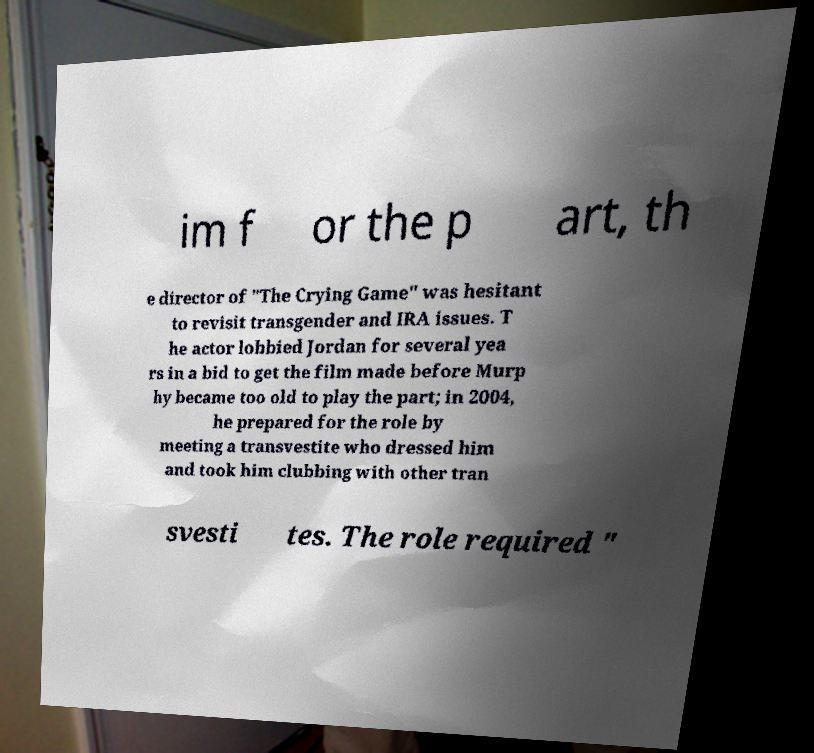Could you assist in decoding the text presented in this image and type it out clearly? im f or the p art, th e director of "The Crying Game" was hesitant to revisit transgender and IRA issues. T he actor lobbied Jordan for several yea rs in a bid to get the film made before Murp hy became too old to play the part; in 2004, he prepared for the role by meeting a transvestite who dressed him and took him clubbing with other tran svesti tes. The role required " 